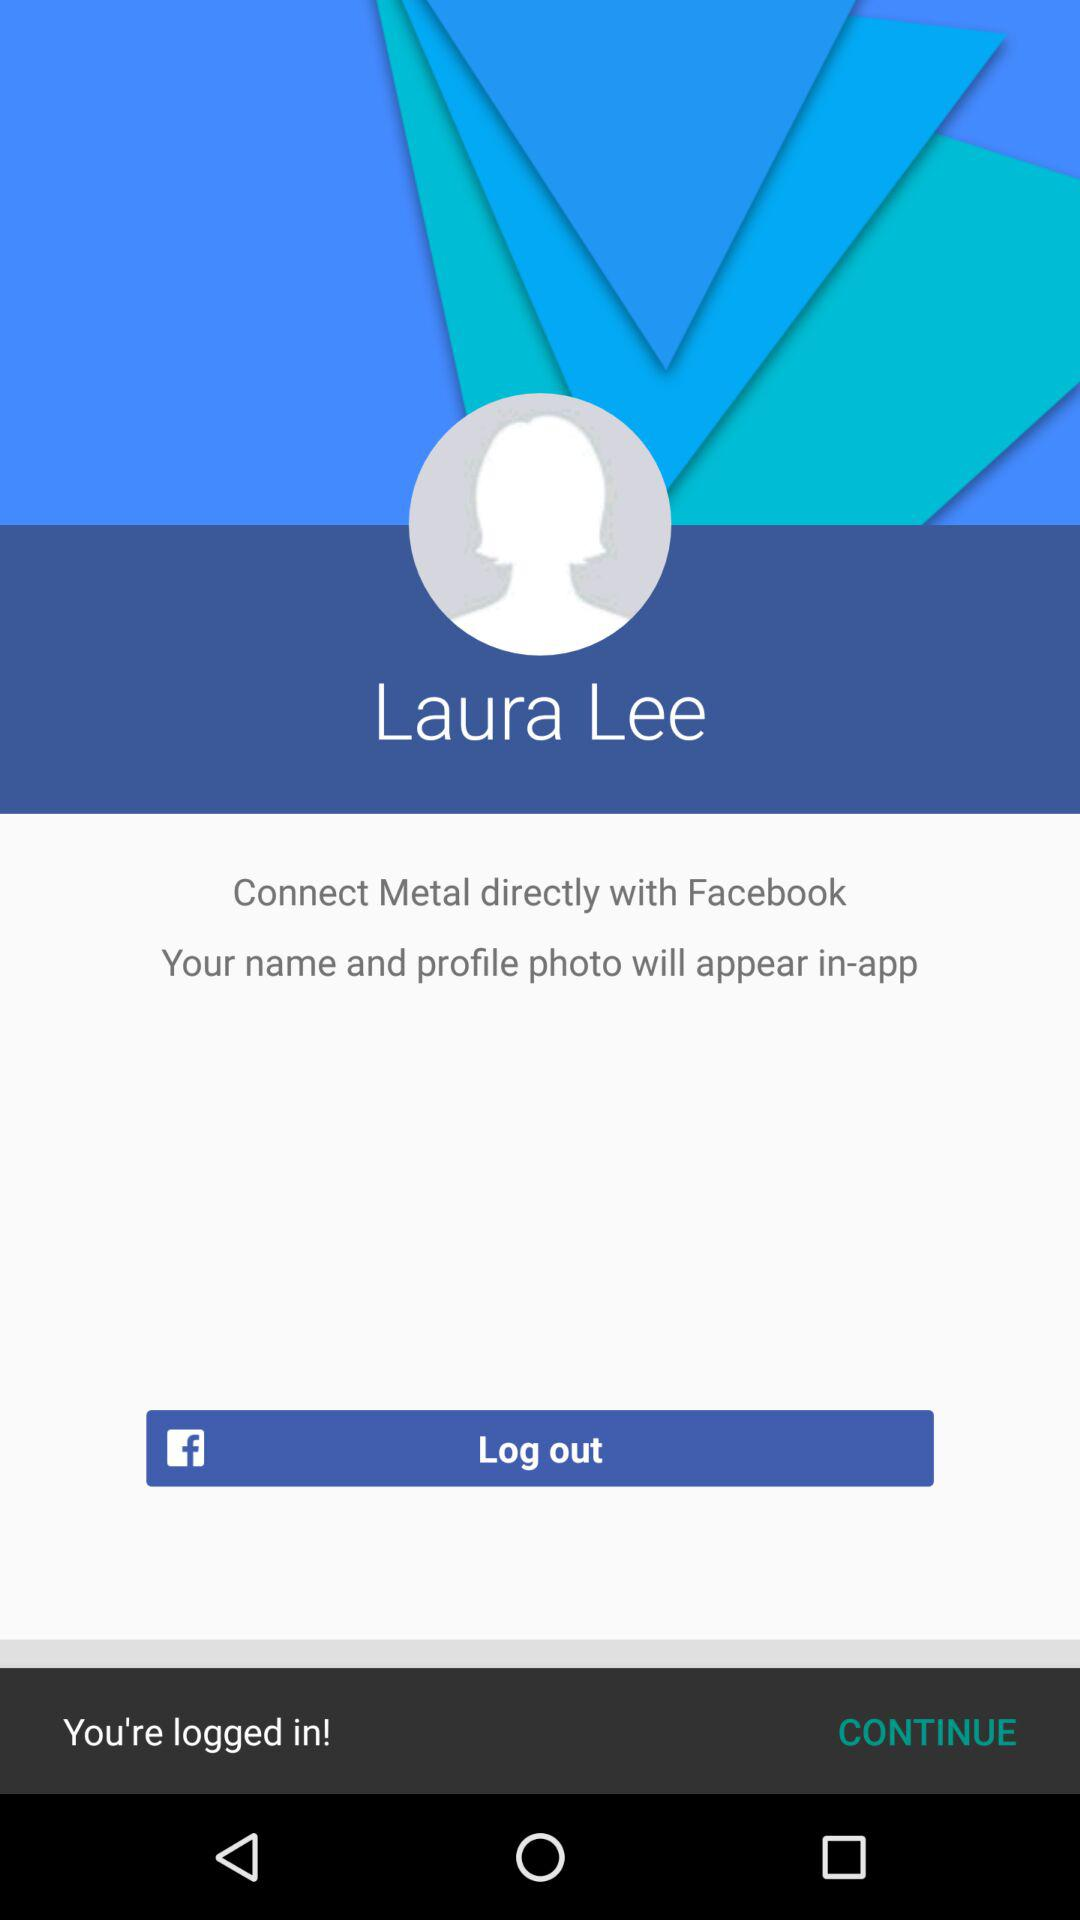What is the login name? The login name is Laura Lee. 